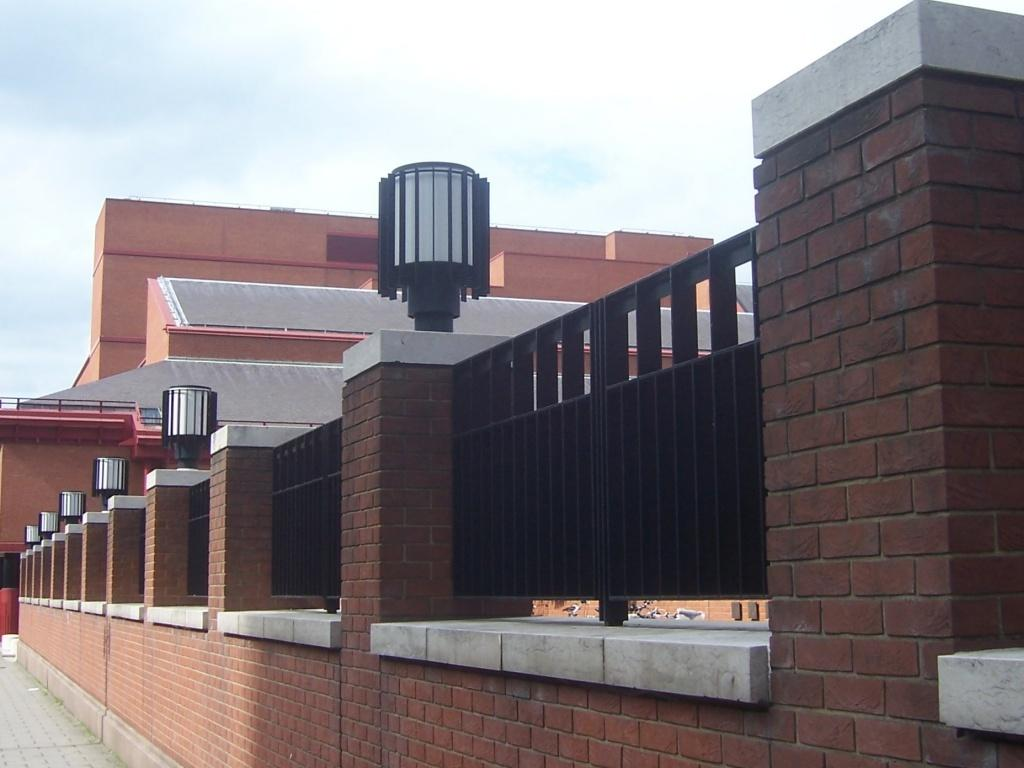What structure is located on the right side of the image? There is a pillar on the right side of the image. What can be seen in the center of the image? There are buildings in the center of the image. What type of tooth is visible on the pillar in the image? There is no tooth present on the pillar in the image. Are there any people wearing masks in the image? There is no information about people or masks in the image; it only features a pillar and buildings. 